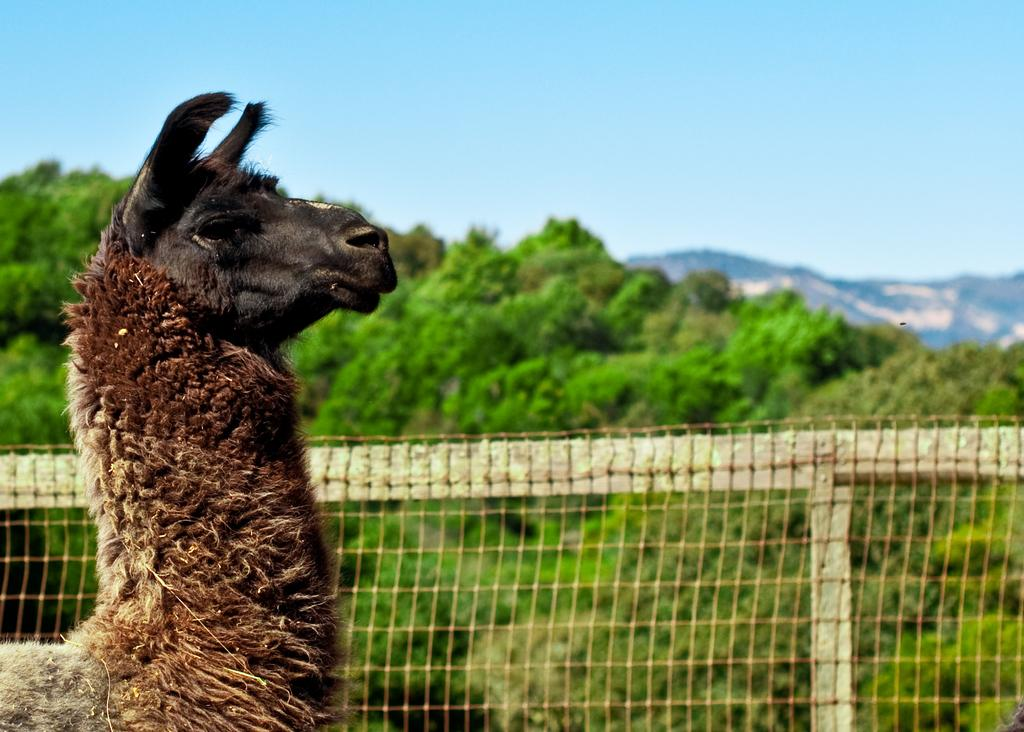What animal is in the front of the image? There is a llama in the front of the image. What is located in the middle of the image? There is fencing in the middle of the image. What type of vegetation can be seen in the background of the image? There are trees in the background of the image. What is visible at the top of the image? The sky is visible at the top of the image. What type of bread is being used to measure the force applied to the llama's tongue in the image? There is no bread or force being applied to the llama's tongue in the image; it only features a llama, fencing, trees, and the sky. 